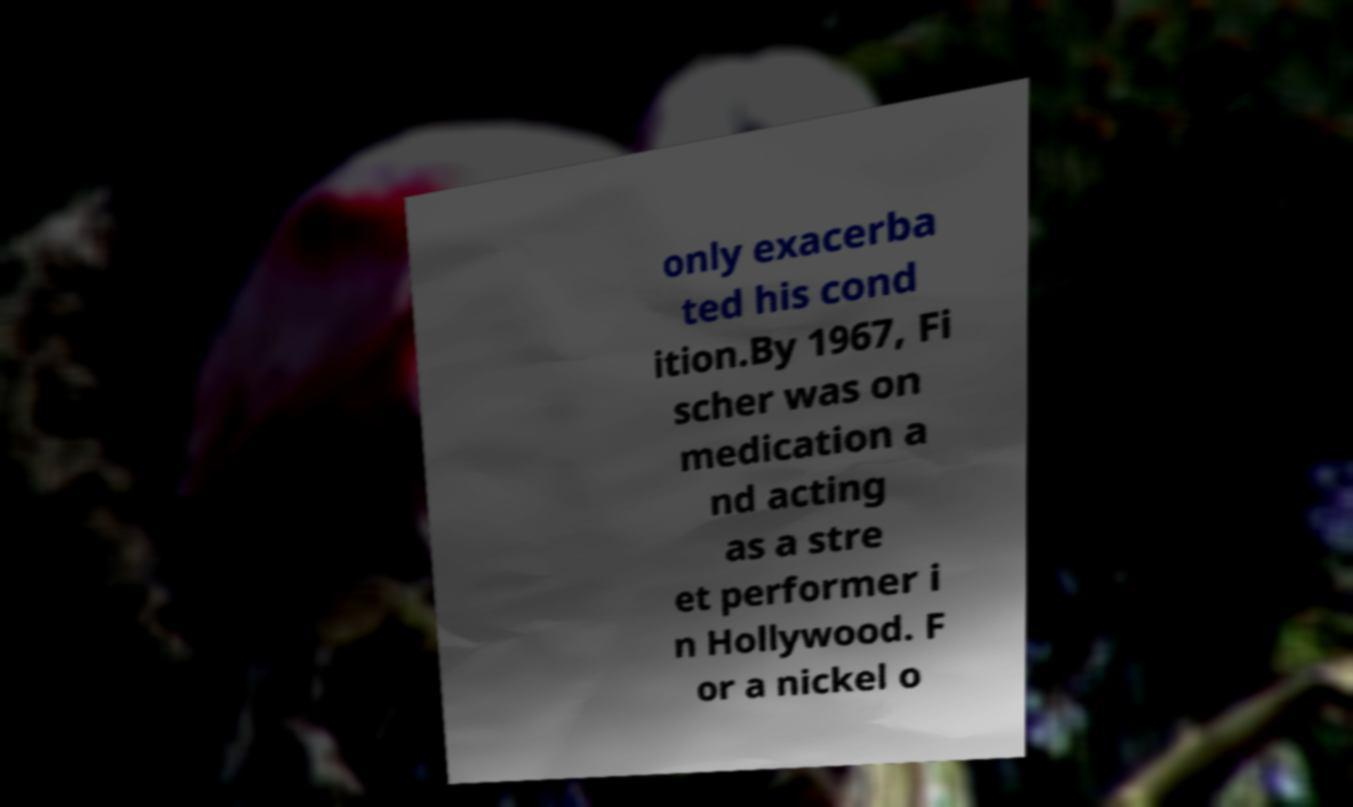Can you accurately transcribe the text from the provided image for me? only exacerba ted his cond ition.By 1967, Fi scher was on medication a nd acting as a stre et performer i n Hollywood. F or a nickel o 